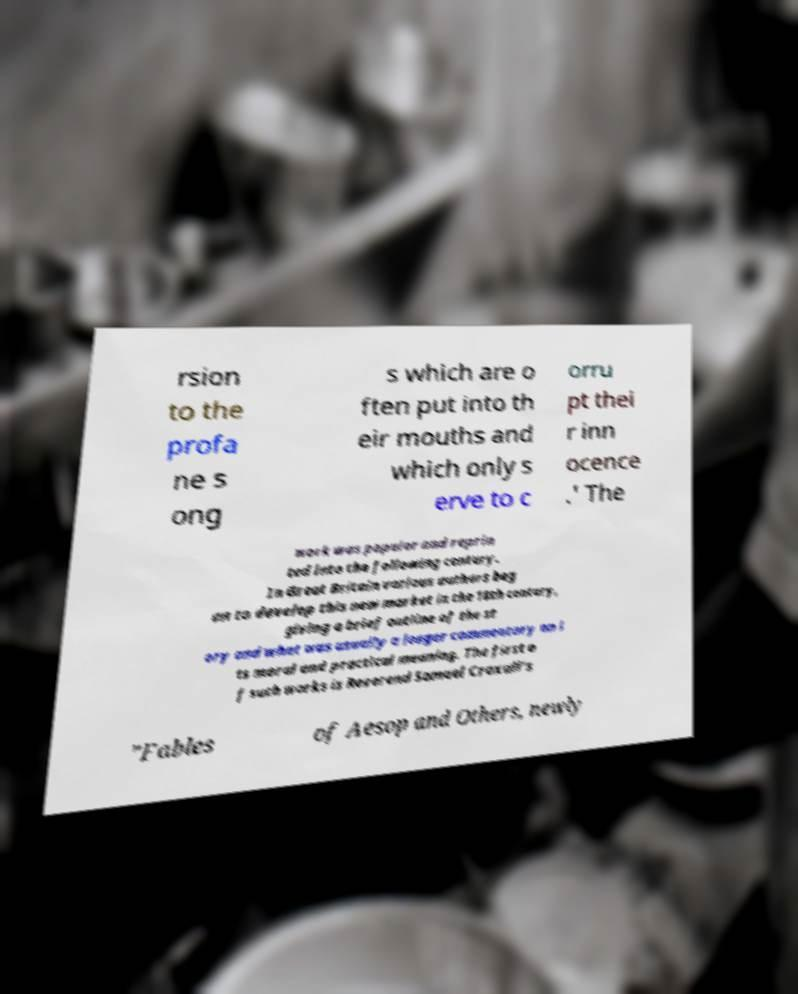I need the written content from this picture converted into text. Can you do that? rsion to the profa ne s ong s which are o ften put into th eir mouths and which only s erve to c orru pt thei r inn ocence .' The work was popular and reprin ted into the following century. In Great Britain various authors beg an to develop this new market in the 18th century, giving a brief outline of the st ory and what was usually a longer commentary on i ts moral and practical meaning. The first o f such works is Reverend Samuel Croxall's "Fables of Aesop and Others, newly 